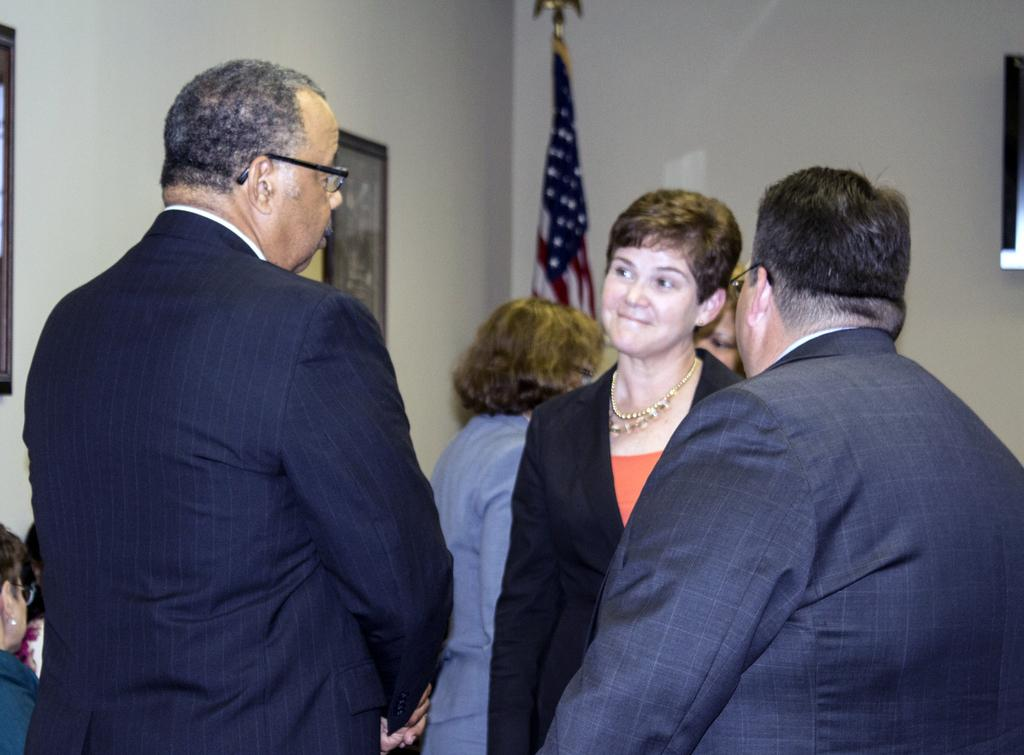Who or what can be seen in the image? There are people in the image. What is on the left side of the image? There is a photo frame on the wall on the left side. What can be seen in the background of the image? There is a flag and a wall in the background. What type of milk is being served in the image? There is no milk present in the image. 